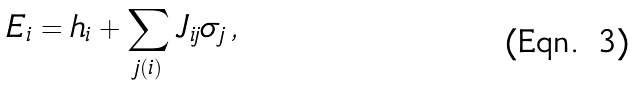<formula> <loc_0><loc_0><loc_500><loc_500>E _ { i } = h _ { i } + \sum _ { j ( i ) } J _ { i j } \sigma _ { j } \, ,</formula> 